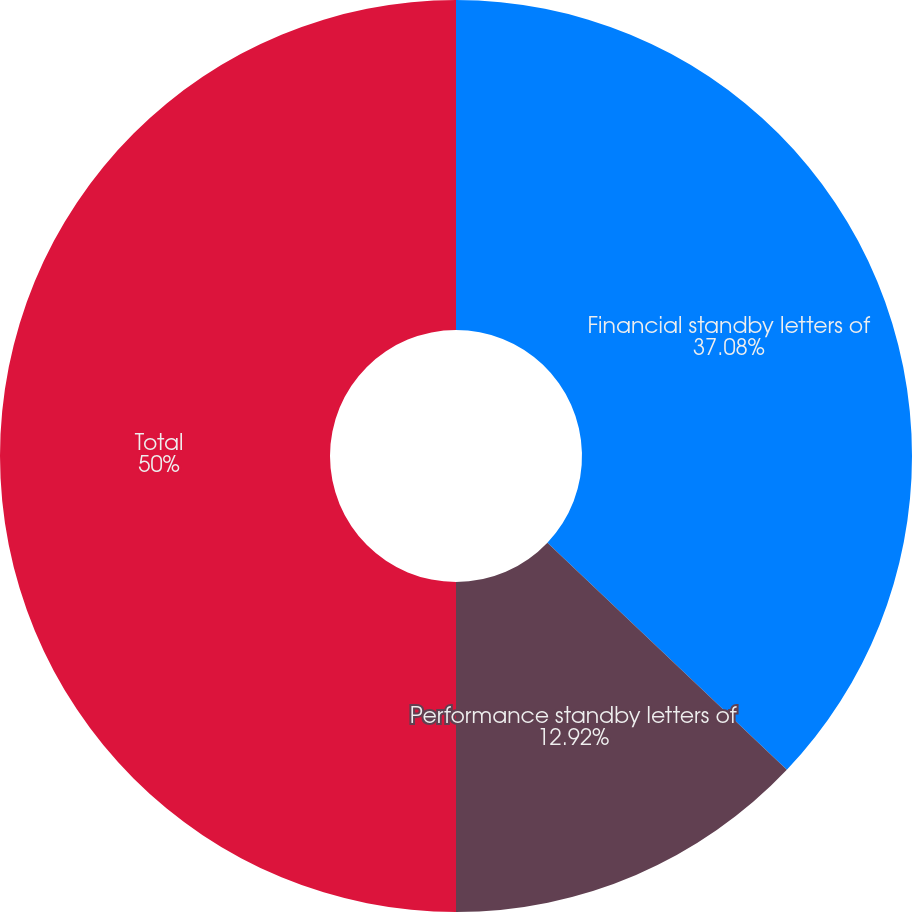<chart> <loc_0><loc_0><loc_500><loc_500><pie_chart><fcel>Financial standby letters of<fcel>Performance standby letters of<fcel>Total<nl><fcel>37.08%<fcel>12.92%<fcel>50.0%<nl></chart> 